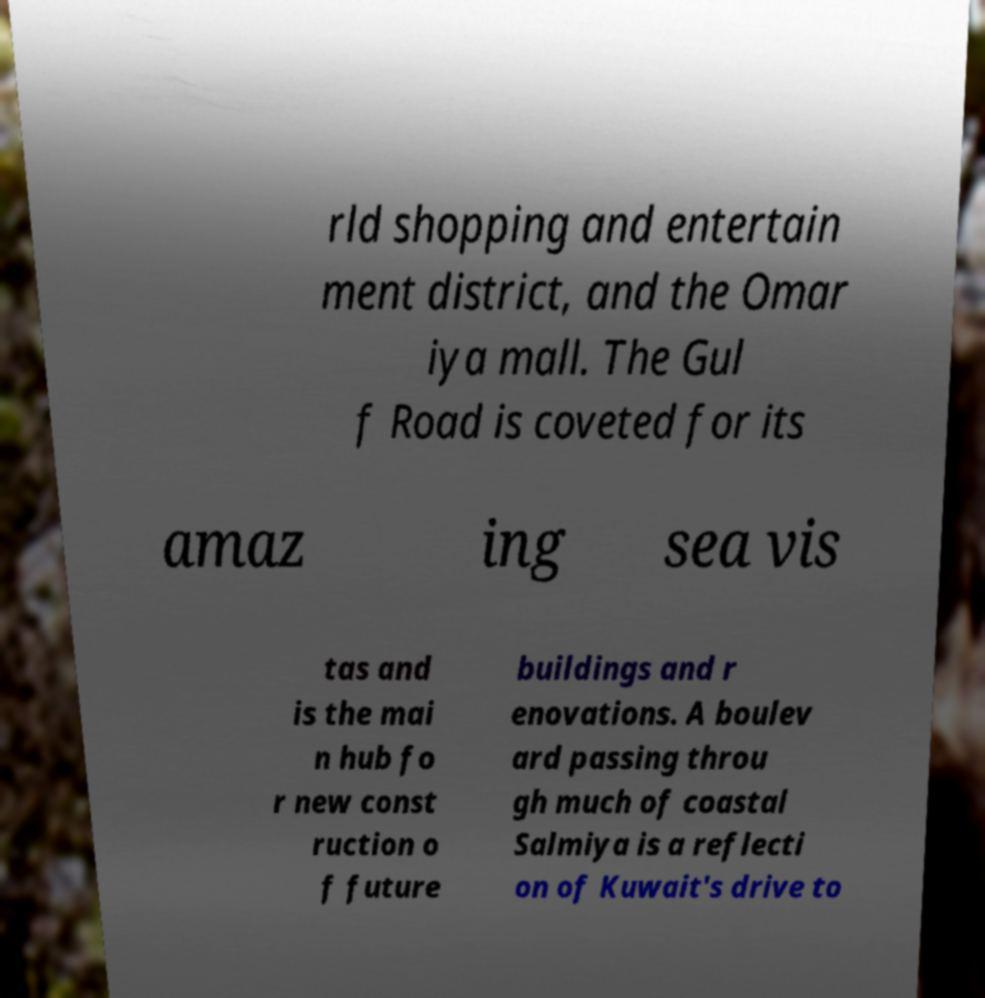Can you accurately transcribe the text from the provided image for me? rld shopping and entertain ment district, and the Omar iya mall. The Gul f Road is coveted for its amaz ing sea vis tas and is the mai n hub fo r new const ruction o f future buildings and r enovations. A boulev ard passing throu gh much of coastal Salmiya is a reflecti on of Kuwait's drive to 